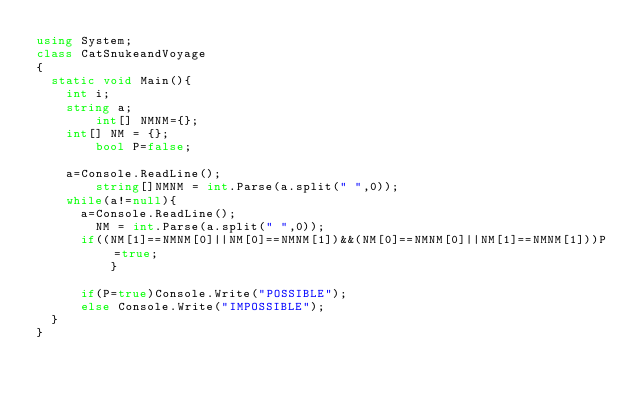Convert code to text. <code><loc_0><loc_0><loc_500><loc_500><_C#_>using System;
class CatSnukeandVoyage
{
	static void Main(){
		int i;
		string a;
      	int[] NMNM={};
		int[] NM = {};
      	bool P=false;
 
 		a=Console.ReadLine();
      	string[]NMNM = int.Parse(a.split(" ",0));
		while(a!=null){
			a=Console.ReadLine();
     		NM = int.Parse(a.split(" ",0));
			if((NM[1]==NMNM[0]||NM[0]==NMNM[1])&&(NM[0]==NMNM[0]||NM[1]==NMNM[1]))P=true;
  				}
      
			if(P=true)Console.Write("POSSIBLE");
			else Console.Write("IMPOSSIBLE");
	}
}</code> 